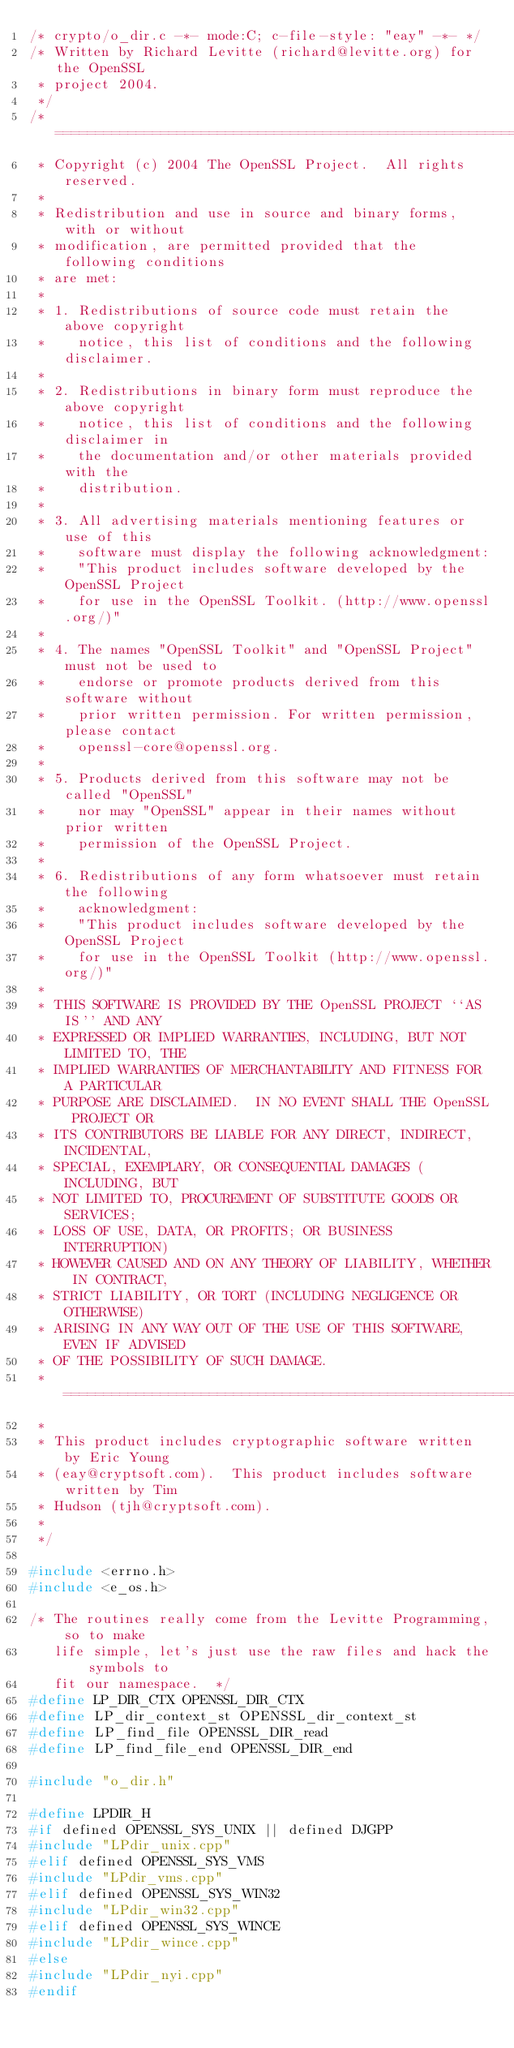<code> <loc_0><loc_0><loc_500><loc_500><_C++_>/* crypto/o_dir.c -*- mode:C; c-file-style: "eay" -*- */
/* Written by Richard Levitte (richard@levitte.org) for the OpenSSL
 * project 2004.
 */
/* ====================================================================
 * Copyright (c) 2004 The OpenSSL Project.  All rights reserved.
 *
 * Redistribution and use in source and binary forms, with or without
 * modification, are permitted provided that the following conditions
 * are met:
 *
 * 1. Redistributions of source code must retain the above copyright
 *    notice, this list of conditions and the following disclaimer. 
 *
 * 2. Redistributions in binary form must reproduce the above copyright
 *    notice, this list of conditions and the following disclaimer in
 *    the documentation and/or other materials provided with the
 *    distribution.
 *
 * 3. All advertising materials mentioning features or use of this
 *    software must display the following acknowledgment:
 *    "This product includes software developed by the OpenSSL Project
 *    for use in the OpenSSL Toolkit. (http://www.openssl.org/)"
 *
 * 4. The names "OpenSSL Toolkit" and "OpenSSL Project" must not be used to
 *    endorse or promote products derived from this software without
 *    prior written permission. For written permission, please contact
 *    openssl-core@openssl.org.
 *
 * 5. Products derived from this software may not be called "OpenSSL"
 *    nor may "OpenSSL" appear in their names without prior written
 *    permission of the OpenSSL Project.
 *
 * 6. Redistributions of any form whatsoever must retain the following
 *    acknowledgment:
 *    "This product includes software developed by the OpenSSL Project
 *    for use in the OpenSSL Toolkit (http://www.openssl.org/)"
 *
 * THIS SOFTWARE IS PROVIDED BY THE OpenSSL PROJECT ``AS IS'' AND ANY
 * EXPRESSED OR IMPLIED WARRANTIES, INCLUDING, BUT NOT LIMITED TO, THE
 * IMPLIED WARRANTIES OF MERCHANTABILITY AND FITNESS FOR A PARTICULAR
 * PURPOSE ARE DISCLAIMED.  IN NO EVENT SHALL THE OpenSSL PROJECT OR
 * ITS CONTRIBUTORS BE LIABLE FOR ANY DIRECT, INDIRECT, INCIDENTAL,
 * SPECIAL, EXEMPLARY, OR CONSEQUENTIAL DAMAGES (INCLUDING, BUT
 * NOT LIMITED TO, PROCUREMENT OF SUBSTITUTE GOODS OR SERVICES;
 * LOSS OF USE, DATA, OR PROFITS; OR BUSINESS INTERRUPTION)
 * HOWEVER CAUSED AND ON ANY THEORY OF LIABILITY, WHETHER IN CONTRACT,
 * STRICT LIABILITY, OR TORT (INCLUDING NEGLIGENCE OR OTHERWISE)
 * ARISING IN ANY WAY OUT OF THE USE OF THIS SOFTWARE, EVEN IF ADVISED
 * OF THE POSSIBILITY OF SUCH DAMAGE.
 * ====================================================================
 *
 * This product includes cryptographic software written by Eric Young
 * (eay@cryptsoft.com).  This product includes software written by Tim
 * Hudson (tjh@cryptsoft.com).
 *
 */

#include <errno.h>
#include <e_os.h>

/* The routines really come from the Levitte Programming, so to make
   life simple, let's just use the raw files and hack the symbols to
   fit our namespace.  */
#define LP_DIR_CTX OPENSSL_DIR_CTX
#define LP_dir_context_st OPENSSL_dir_context_st
#define LP_find_file OPENSSL_DIR_read
#define LP_find_file_end OPENSSL_DIR_end

#include "o_dir.h"

#define LPDIR_H
#if defined OPENSSL_SYS_UNIX || defined DJGPP
#include "LPdir_unix.cpp"
#elif defined OPENSSL_SYS_VMS
#include "LPdir_vms.cpp"
#elif defined OPENSSL_SYS_WIN32
#include "LPdir_win32.cpp"
#elif defined OPENSSL_SYS_WINCE
#include "LPdir_wince.cpp"
#else
#include "LPdir_nyi.cpp"
#endif
</code> 